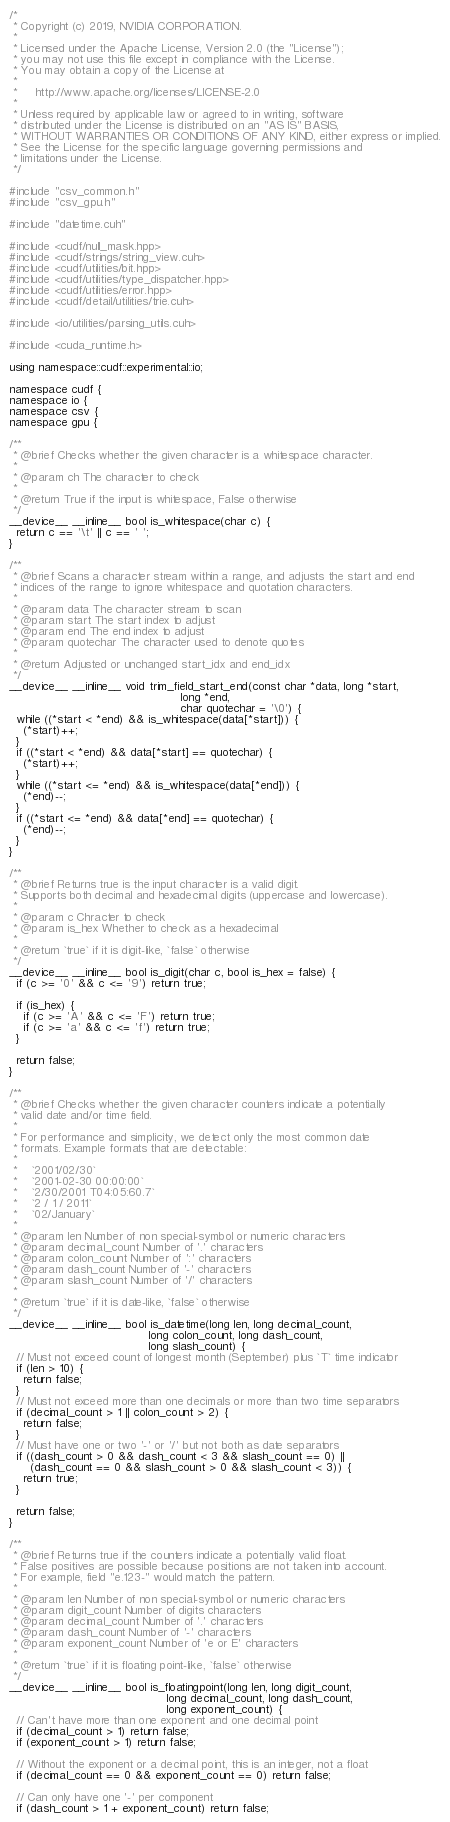Convert code to text. <code><loc_0><loc_0><loc_500><loc_500><_Cuda_>/*
 * Copyright (c) 2019, NVIDIA CORPORATION.
 *
 * Licensed under the Apache License, Version 2.0 (the "License");
 * you may not use this file except in compliance with the License.
 * You may obtain a copy of the License at
 *
 *     http://www.apache.org/licenses/LICENSE-2.0
 *
 * Unless required by applicable law or agreed to in writing, software
 * distributed under the License is distributed on an "AS IS" BASIS,
 * WITHOUT WARRANTIES OR CONDITIONS OF ANY KIND, either express or implied.
 * See the License for the specific language governing permissions and
 * limitations under the License.
 */

#include "csv_common.h"
#include "csv_gpu.h"

#include "datetime.cuh"

#include <cudf/null_mask.hpp>
#include <cudf/strings/string_view.cuh>
#include <cudf/utilities/bit.hpp>
#include <cudf/utilities/type_dispatcher.hpp>
#include <cudf/utilities/error.hpp>
#include <cudf/detail/utilities/trie.cuh>

#include <io/utilities/parsing_utils.cuh>

#include <cuda_runtime.h>

using namespace::cudf::experimental::io;

namespace cudf {
namespace io {
namespace csv {
namespace gpu {

/**
 * @brief Checks whether the given character is a whitespace character.
 *
 * @param ch The character to check
 *
 * @return True if the input is whitespace, False otherwise
 */
__device__ __inline__ bool is_whitespace(char c) {
  return c == '\t' || c == ' ';
}

/**
 * @brief Scans a character stream within a range, and adjusts the start and end
 * indices of the range to ignore whitespace and quotation characters.
 *
 * @param data The character stream to scan
 * @param start The start index to adjust
 * @param end The end index to adjust
 * @param quotechar The character used to denote quotes
 *
 * @return Adjusted or unchanged start_idx and end_idx
 */
__device__ __inline__ void trim_field_start_end(const char *data, long *start,
                                                long *end,
                                                char quotechar = '\0') {
  while ((*start < *end) && is_whitespace(data[*start])) {
    (*start)++;
  }
  if ((*start < *end) && data[*start] == quotechar) {
    (*start)++;
  }
  while ((*start <= *end) && is_whitespace(data[*end])) {
    (*end)--;
  }
  if ((*start <= *end) && data[*end] == quotechar) {
    (*end)--;
  }
}

/**
 * @brief Returns true is the input character is a valid digit.
 * Supports both decimal and hexadecimal digits (uppercase and lowercase).
 *
 * @param c Chracter to check
 * @param is_hex Whether to check as a hexadecimal
 *
 * @return `true` if it is digit-like, `false` otherwise
 */
__device__ __inline__ bool is_digit(char c, bool is_hex = false) {
  if (c >= '0' && c <= '9') return true;

  if (is_hex) {
    if (c >= 'A' && c <= 'F') return true;
    if (c >= 'a' && c <= 'f') return true;
  }

  return false;
}

/**
 * @brief Checks whether the given character counters indicate a potentially
 * valid date and/or time field.
 *
 * For performance and simplicity, we detect only the most common date
 * formats. Example formats that are detectable:
 *
 *    `2001/02/30`
 *    `2001-02-30 00:00:00`
 *    `2/30/2001 T04:05:60.7`
 *    `2 / 1 / 2011`
 *    `02/January`
 *
 * @param len Number of non special-symbol or numeric characters
 * @param decimal_count Number of '.' characters
 * @param colon_count Number of ':' characters
 * @param dash_count Number of '-' characters
 * @param slash_count Number of '/' characters
 *
 * @return `true` if it is date-like, `false` otherwise
 */
__device__ __inline__ bool is_datetime(long len, long decimal_count,
                                       long colon_count, long dash_count,
                                       long slash_count) {
  // Must not exceed count of longest month (September) plus `T` time indicator
  if (len > 10) {
    return false;
  }
  // Must not exceed more than one decimals or more than two time separators
  if (decimal_count > 1 || colon_count > 2) {
    return false;
  }
  // Must have one or two '-' or '/' but not both as date separators
  if ((dash_count > 0 && dash_count < 3 && slash_count == 0) ||
      (dash_count == 0 && slash_count > 0 && slash_count < 3)) {
    return true;
  }

  return false;
}

/**
 * @brief Returns true if the counters indicate a potentially valid float.
 * False positives are possible because positions are not taken into account.
 * For example, field "e.123-" would match the pattern.
 *
 * @param len Number of non special-symbol or numeric characters
 * @param digit_count Number of digits characters
 * @param decimal_count Number of '.' characters
 * @param dash_count Number of '-' characters
 * @param exponent_count Number of 'e or E' characters
 *
 * @return `true` if it is floating point-like, `false` otherwise
 */
__device__ __inline__ bool is_floatingpoint(long len, long digit_count,
                                            long decimal_count, long dash_count,
                                            long exponent_count) {
  // Can't have more than one exponent and one decimal point
  if (decimal_count > 1) return false;
  if (exponent_count > 1) return false;

  // Without the exponent or a decimal point, this is an integer, not a float
  if (decimal_count == 0 && exponent_count == 0) return false;

  // Can only have one '-' per component
  if (dash_count > 1 + exponent_count) return false;
</code> 